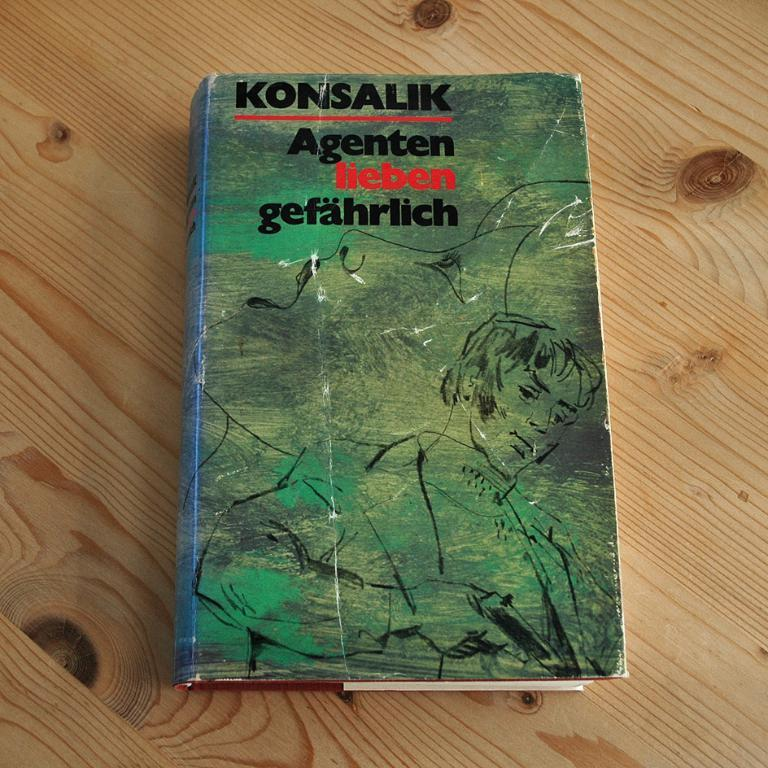<image>
Present a compact description of the photo's key features. Book that is made by Konsalik with a Green background a woman holding a gun. 